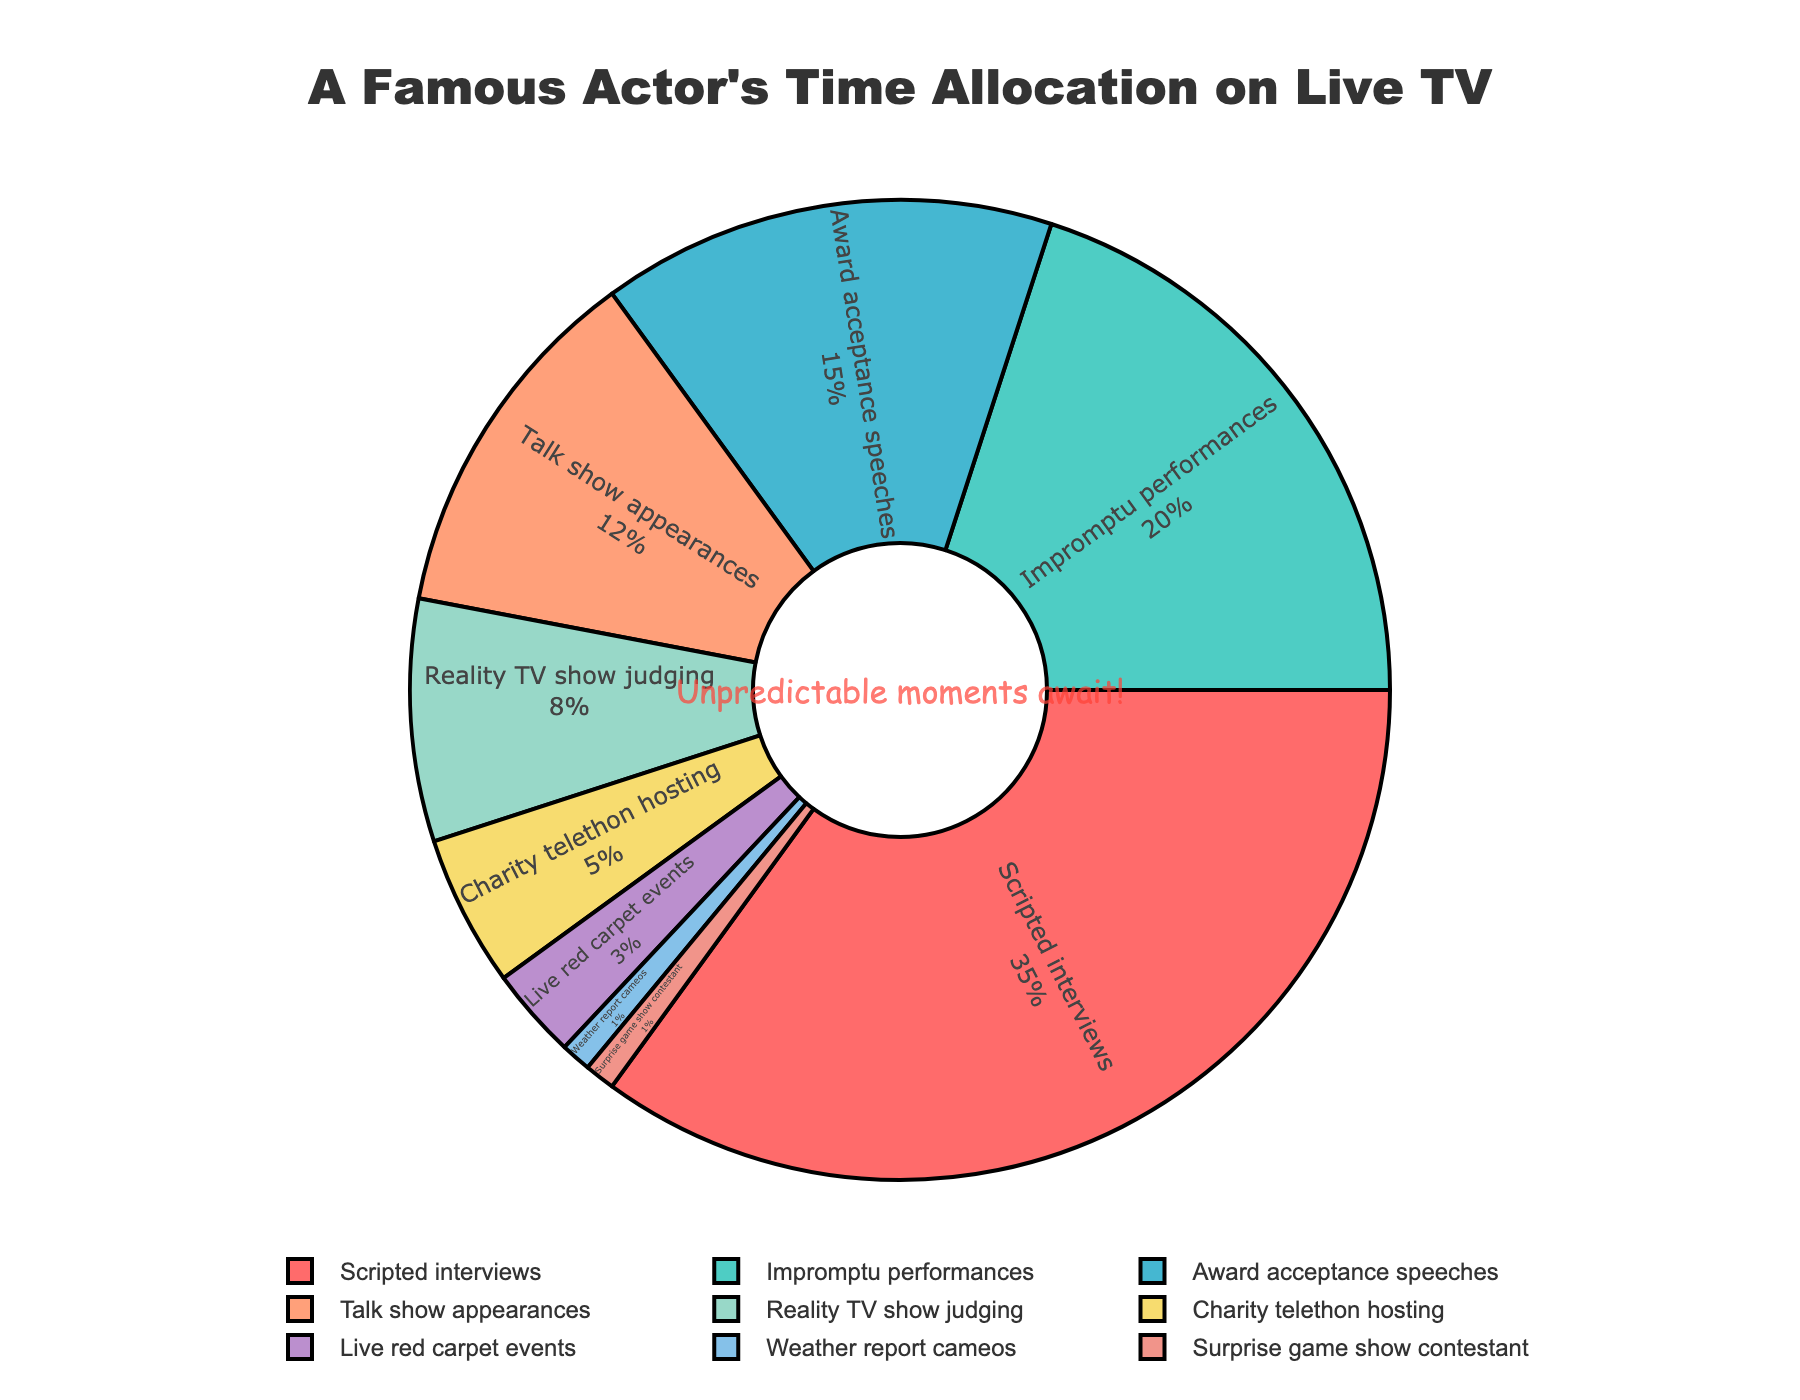Which segment takes up the largest portion of the actor's time allocation on live TV? The figure shows the percentage contribution of each segment in a pie chart. By observing the largest slice, we can see that "Scripted interviews" takes up the largest portion.
Answer: Scripted interviews How much more time is allocated to impromptu performances compared to live red carpet events? We need to find the difference in percentages between "Impromptu performances" (20%) and "Live red carpet events" (3%). The difference is 20% - 3% = 17%.
Answer: 17% Which two segments combined account for exactly one-fifth of the actor's time on live TV? To find segments that add up to 20%, we look for pairs: "Reality TV show judging" (8%) + "Charity telethon hosting" (5%) = 13%, and "Live red carpet events" (3%) + "Weather report cameos" (1%) + "Surprise game show contestant" (1%) = 5%. The only pair that adds up to 20% is not present, so we check other possible combination summing to 20% and find that "Impromptu performances" (20%) is the correct answer.
Answer: Impromptu performances Among the segments, which one has the least allocated time? By identifying the smallest slice of the pie chart, we observe that "Weather report cameos" and "Surprise game show contestant" both share the least allocated time at 1% each.
Answer: Weather report cameos; Surprise game show contestant By how much does the time spent on talk show appearances exceed the time spent on reality TV show judging? Comparing the two segments' percentages, "Talk show appearances" (12%) and "Reality TV show judging" (8%), we find the difference: 12% - 8% = 4%.
Answer: 4% What is the combined percentage of time allocated to scripted interviews, impromptu performances, and award acceptance speeches? Add the percentages of "Scripted interviews" (35%), "Impromptu performances" (20%), and "Award acceptance speeches" (15%): 35% + 20% + 15% = 70%.
Answer: 70% Which segment's time allocation is represented by the color closest to blue? Observing the pie chart's color legend, "Talk show appearances" is represented by a blue-like color.
Answer: Talk show appearances What fraction of the actor's time is spent on segments other than scripted interviews? Subtract the percentage allocated to "Scripted interviews" (35%) from 100%, representing the total: 100% - 35% = 65%. This is the fraction of time spent on other segments.
Answer: 65% If the actor were to double their time spent on reality TV show judging, what would the new percentage be? Currently, "Reality TV show judging" is 8%. Doubling it gives us 8% * 2 = 16%.
Answer: 16% 